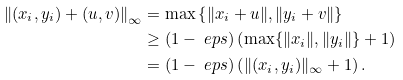Convert formula to latex. <formula><loc_0><loc_0><loc_500><loc_500>\left \| ( x _ { i } , y _ { i } ) + ( u , v ) \right \| _ { \infty } & = \max \left \{ \| x _ { i } + u \| , \| y _ { i } + v \| \right \} \\ & \geq ( 1 - \ e p s ) \left ( \max \{ \| x _ { i } \| , \| y _ { i } \| \} + 1 \right ) \\ & = ( 1 - \ e p s ) \left ( \| ( x _ { i } , y _ { i } ) \| _ { \infty } + 1 \right ) .</formula> 